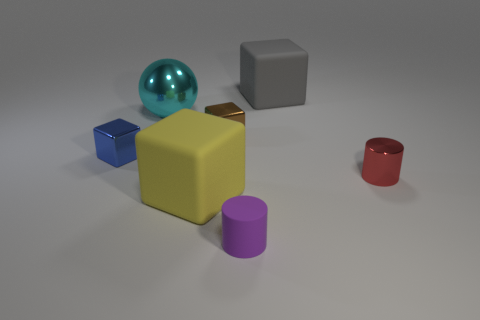The purple cylinder has what size?
Keep it short and to the point. Small. Are the large object that is in front of the cyan sphere and the red cylinder made of the same material?
Your answer should be compact. No. Is the shape of the yellow matte thing the same as the small brown metallic thing?
Make the answer very short. Yes. What shape is the object that is in front of the large cube that is in front of the tiny block that is on the left side of the big cyan metallic ball?
Provide a succinct answer. Cylinder. Does the tiny object behind the tiny blue object have the same shape as the big rubber object in front of the large cyan metal ball?
Your answer should be very brief. Yes. Are there any big objects that have the same material as the blue block?
Provide a succinct answer. Yes. There is a large matte cube that is in front of the large matte object that is behind the big rubber cube that is in front of the red object; what color is it?
Offer a terse response. Yellow. Does the cylinder that is behind the yellow matte thing have the same material as the small cube that is in front of the small brown cube?
Keep it short and to the point. Yes. There is a large thing that is on the right side of the yellow block; what is its shape?
Make the answer very short. Cube. What number of objects are big yellow cubes or big matte blocks in front of the red object?
Provide a succinct answer. 1. 